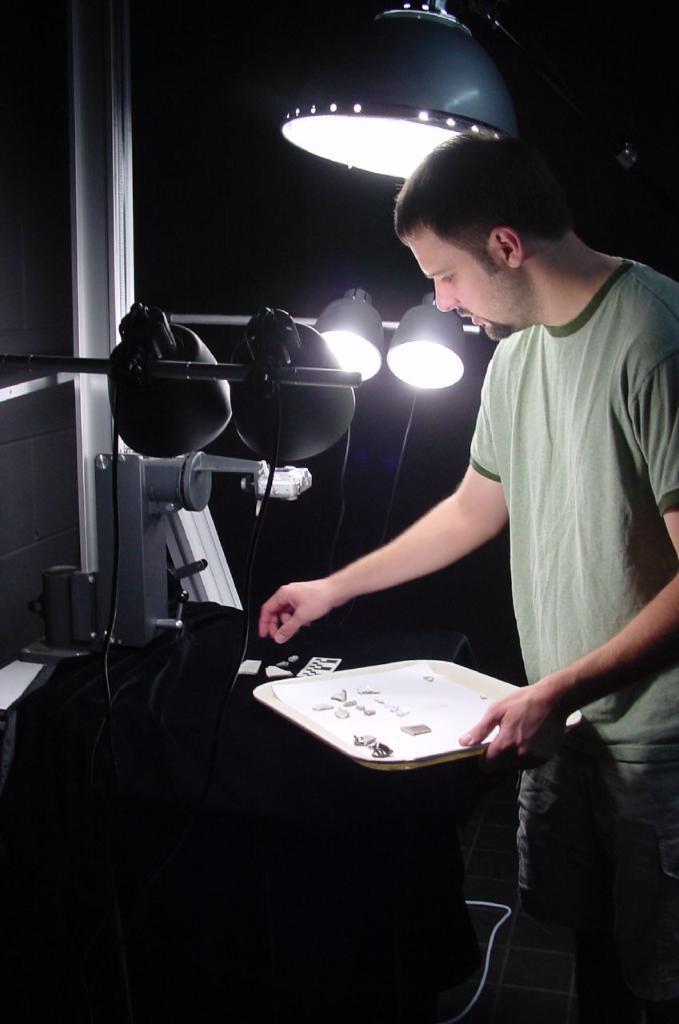Could you give a brief overview of what you see in this image? In this image we can see a person is holding some object. There are few objects are placed on the wooden object. There are few lamps in the image. 